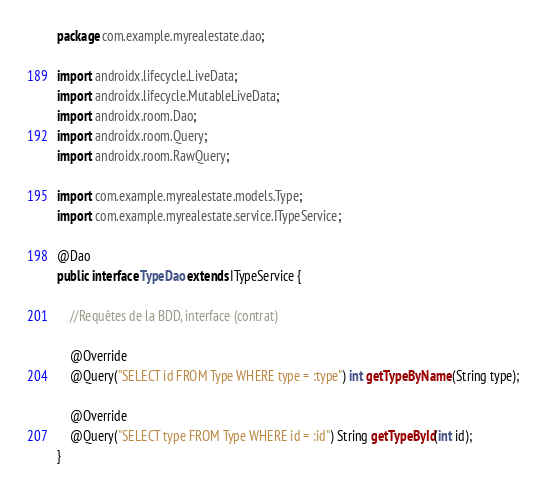<code> <loc_0><loc_0><loc_500><loc_500><_Java_>package com.example.myrealestate.dao;

import androidx.lifecycle.LiveData;
import androidx.lifecycle.MutableLiveData;
import androidx.room.Dao;
import androidx.room.Query;
import androidx.room.RawQuery;

import com.example.myrealestate.models.Type;
import com.example.myrealestate.service.ITypeService;

@Dao
public interface TypeDao extends ITypeService {

    //Requêtes de la BDD, interface (contrat)

    @Override
    @Query("SELECT id FROM Type WHERE type = :type") int getTypeByName (String type);

    @Override
    @Query("SELECT type FROM Type WHERE id = :id") String getTypeById(int id);
}
</code> 